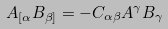<formula> <loc_0><loc_0><loc_500><loc_500>A _ { [ \alpha } B _ { \beta ] } = - C _ { \alpha \beta } A ^ { \gamma } B _ { \gamma }</formula> 